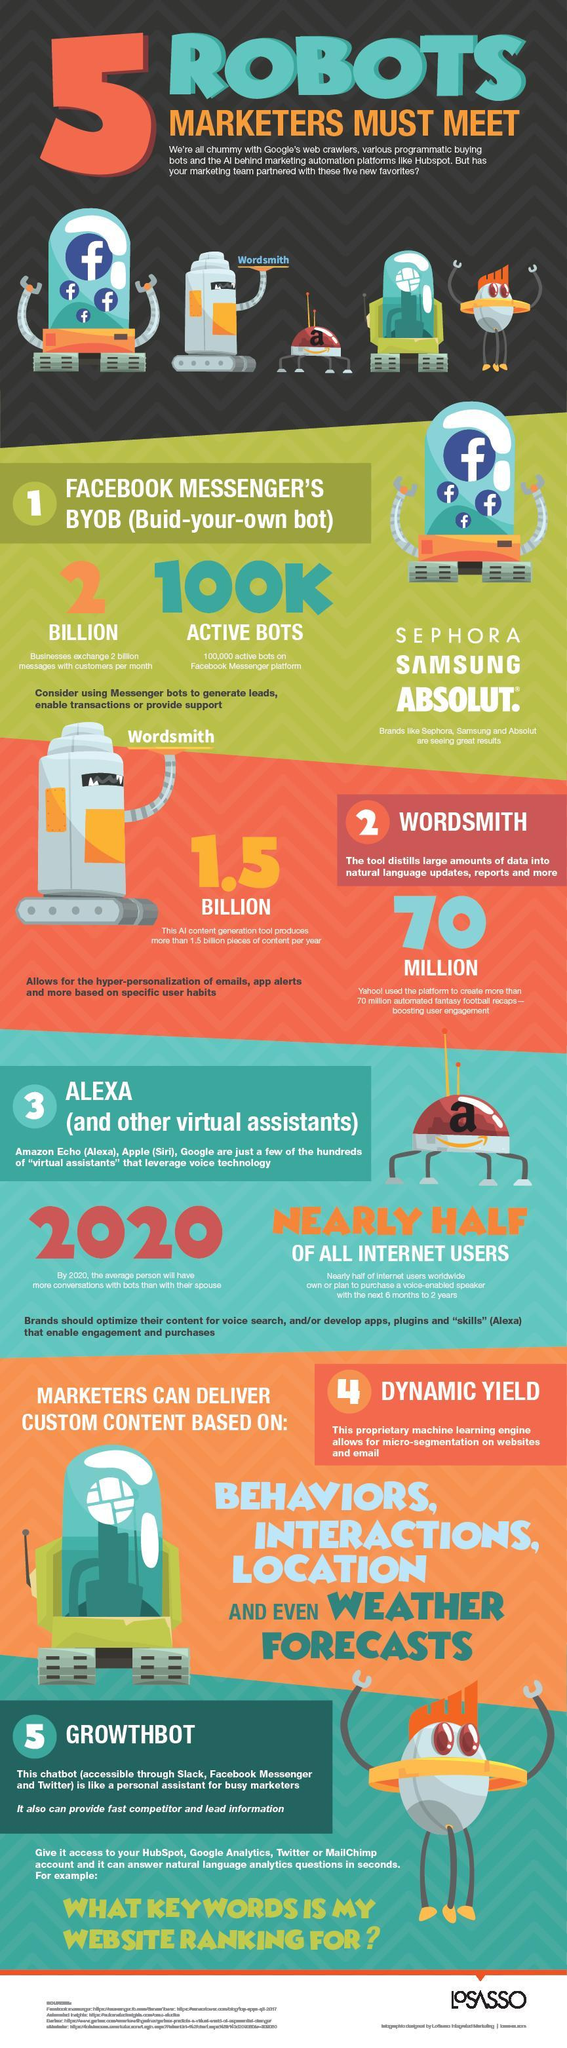What is Alexa
Answer the question with a short phrase. Virtual Assistant Which companies are using Facebook Messenger's BYOB Sephora, Samsung and Absolut What is the colour of the eye of growthbot, red or white red Marketers can deliver custom content based on what? Behaviors, Interactions, Location and even weather forecasts Which online platform used wordsmith yahoo 